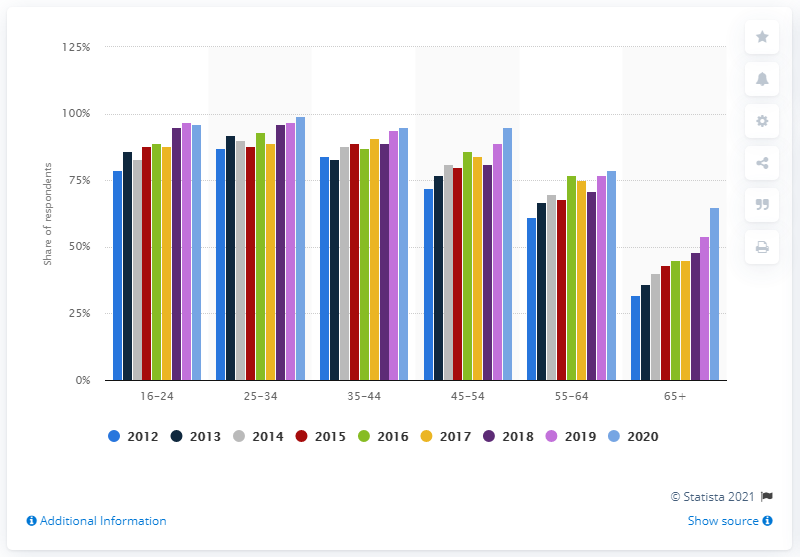Identify some key points in this picture. According to the data, the 65+ age group is the age group that purchases the least amount of items online. In 2020, the online purchasing percentage in the 25-34 age group was 99%. 